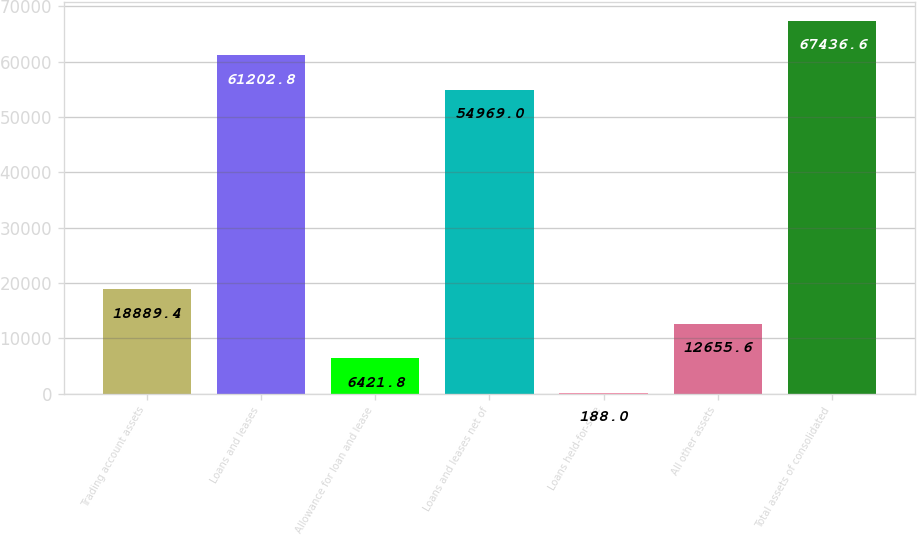Convert chart to OTSL. <chart><loc_0><loc_0><loc_500><loc_500><bar_chart><fcel>Trading account assets<fcel>Loans and leases<fcel>Allowance for loan and lease<fcel>Loans and leases net of<fcel>Loans held-for-sale<fcel>All other assets<fcel>Total assets of consolidated<nl><fcel>18889.4<fcel>61202.8<fcel>6421.8<fcel>54969<fcel>188<fcel>12655.6<fcel>67436.6<nl></chart> 